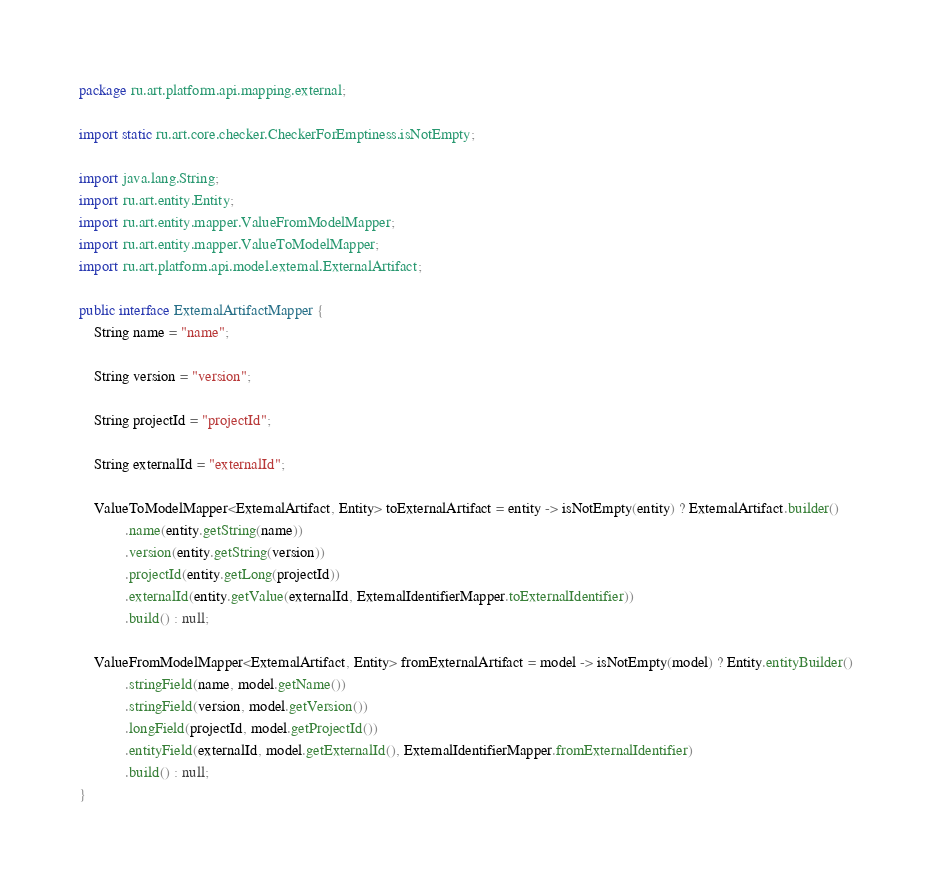<code> <loc_0><loc_0><loc_500><loc_500><_Java_>package ru.art.platform.api.mapping.external;

import static ru.art.core.checker.CheckerForEmptiness.isNotEmpty;

import java.lang.String;
import ru.art.entity.Entity;
import ru.art.entity.mapper.ValueFromModelMapper;
import ru.art.entity.mapper.ValueToModelMapper;
import ru.art.platform.api.model.external.ExternalArtifact;

public interface ExternalArtifactMapper {
	String name = "name";

	String version = "version";

	String projectId = "projectId";

	String externalId = "externalId";

	ValueToModelMapper<ExternalArtifact, Entity> toExternalArtifact = entity -> isNotEmpty(entity) ? ExternalArtifact.builder()
			.name(entity.getString(name))
			.version(entity.getString(version))
			.projectId(entity.getLong(projectId))
			.externalId(entity.getValue(externalId, ExternalIdentifierMapper.toExternalIdentifier))
			.build() : null;

	ValueFromModelMapper<ExternalArtifact, Entity> fromExternalArtifact = model -> isNotEmpty(model) ? Entity.entityBuilder()
			.stringField(name, model.getName())
			.stringField(version, model.getVersion())
			.longField(projectId, model.getProjectId())
			.entityField(externalId, model.getExternalId(), ExternalIdentifierMapper.fromExternalIdentifier)
			.build() : null;
}
</code> 